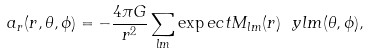<formula> <loc_0><loc_0><loc_500><loc_500>a _ { r } ( r , \theta , \phi ) = - \frac { 4 \pi G } { r ^ { 2 } } \sum _ { l m } \exp e c t { M _ { l m } ( r ) } \ y l m ( \theta , \phi ) ,</formula> 